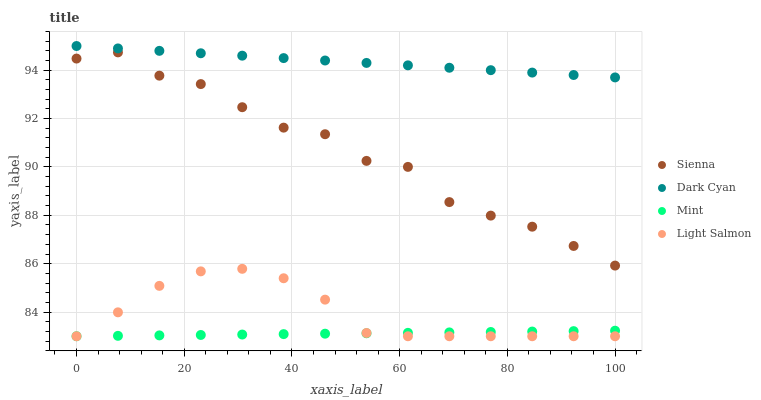Does Mint have the minimum area under the curve?
Answer yes or no. Yes. Does Dark Cyan have the maximum area under the curve?
Answer yes or no. Yes. Does Light Salmon have the minimum area under the curve?
Answer yes or no. No. Does Light Salmon have the maximum area under the curve?
Answer yes or no. No. Is Mint the smoothest?
Answer yes or no. Yes. Is Sienna the roughest?
Answer yes or no. Yes. Is Dark Cyan the smoothest?
Answer yes or no. No. Is Dark Cyan the roughest?
Answer yes or no. No. Does Light Salmon have the lowest value?
Answer yes or no. Yes. Does Dark Cyan have the lowest value?
Answer yes or no. No. Does Dark Cyan have the highest value?
Answer yes or no. Yes. Does Light Salmon have the highest value?
Answer yes or no. No. Is Light Salmon less than Dark Cyan?
Answer yes or no. Yes. Is Dark Cyan greater than Sienna?
Answer yes or no. Yes. Does Light Salmon intersect Mint?
Answer yes or no. Yes. Is Light Salmon less than Mint?
Answer yes or no. No. Is Light Salmon greater than Mint?
Answer yes or no. No. Does Light Salmon intersect Dark Cyan?
Answer yes or no. No. 